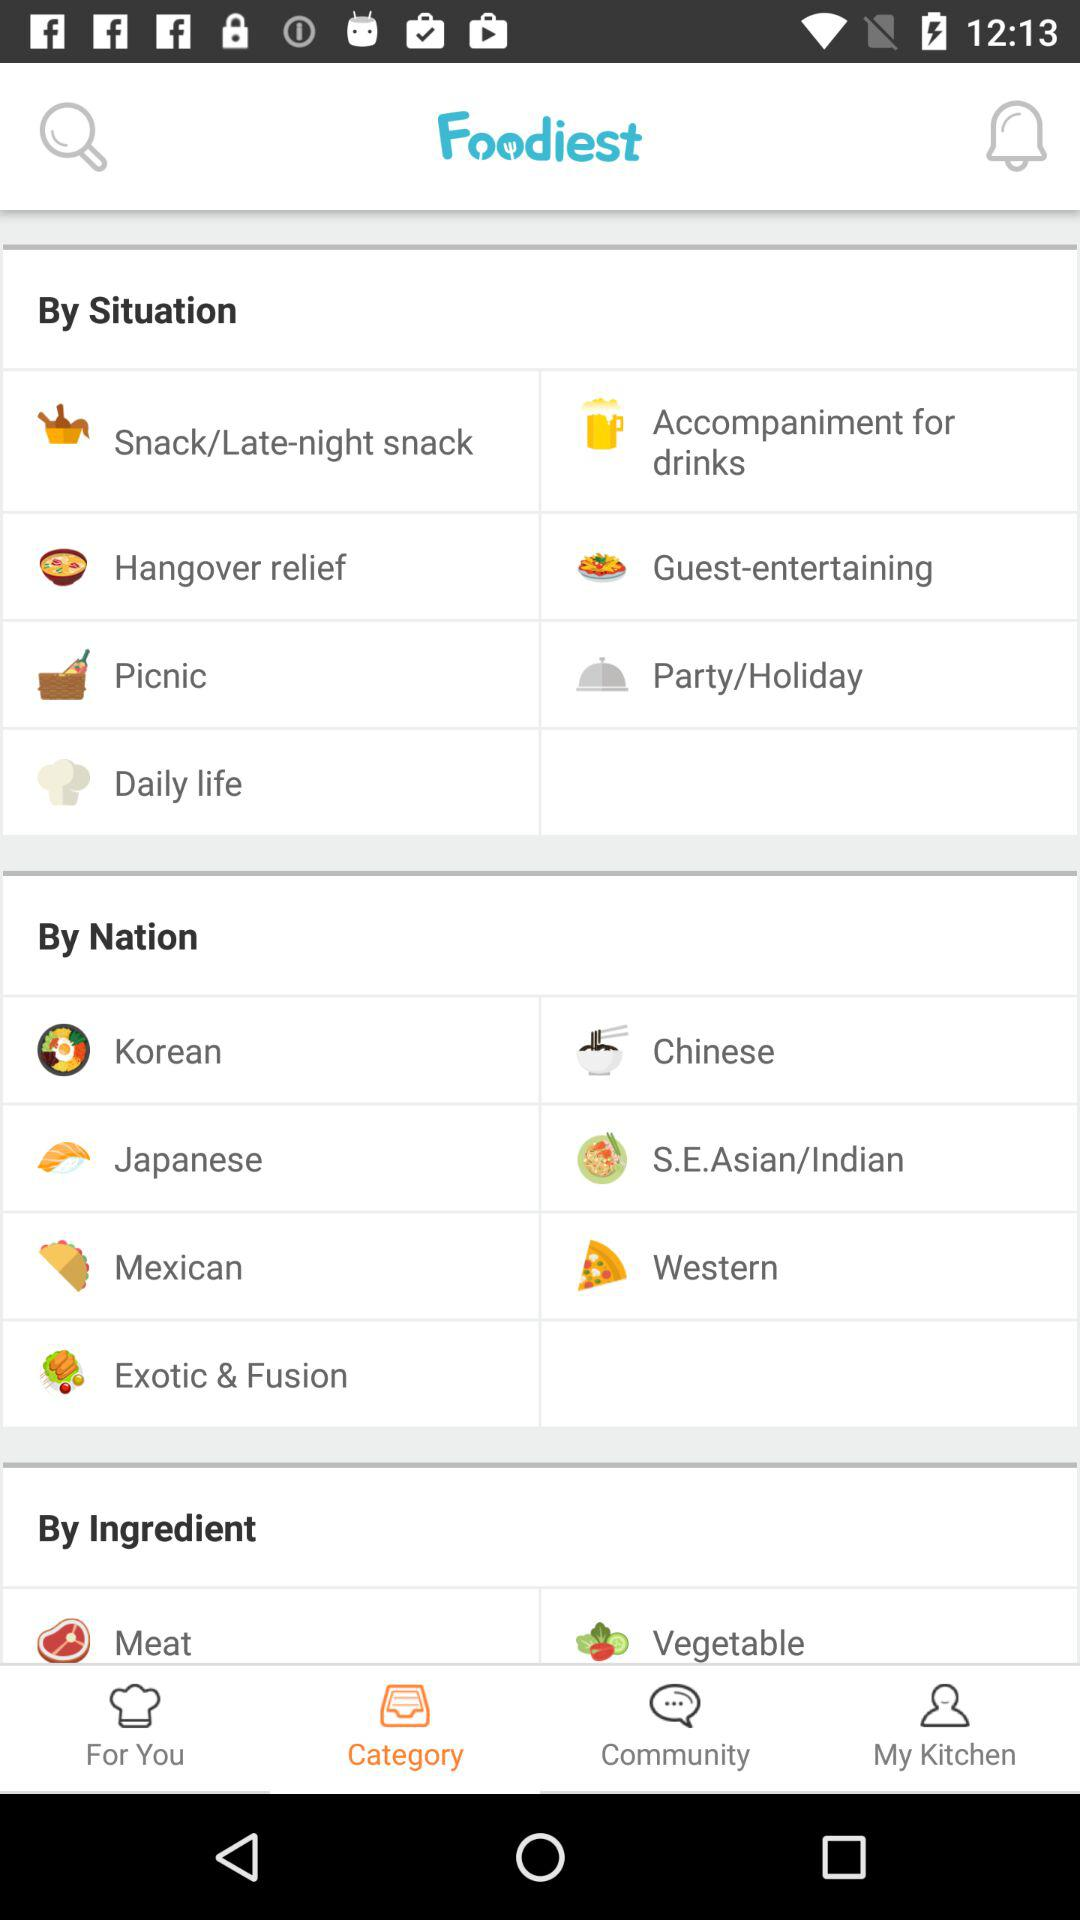How many items are in the 'By Ingredient' section?
Answer the question using a single word or phrase. 2 